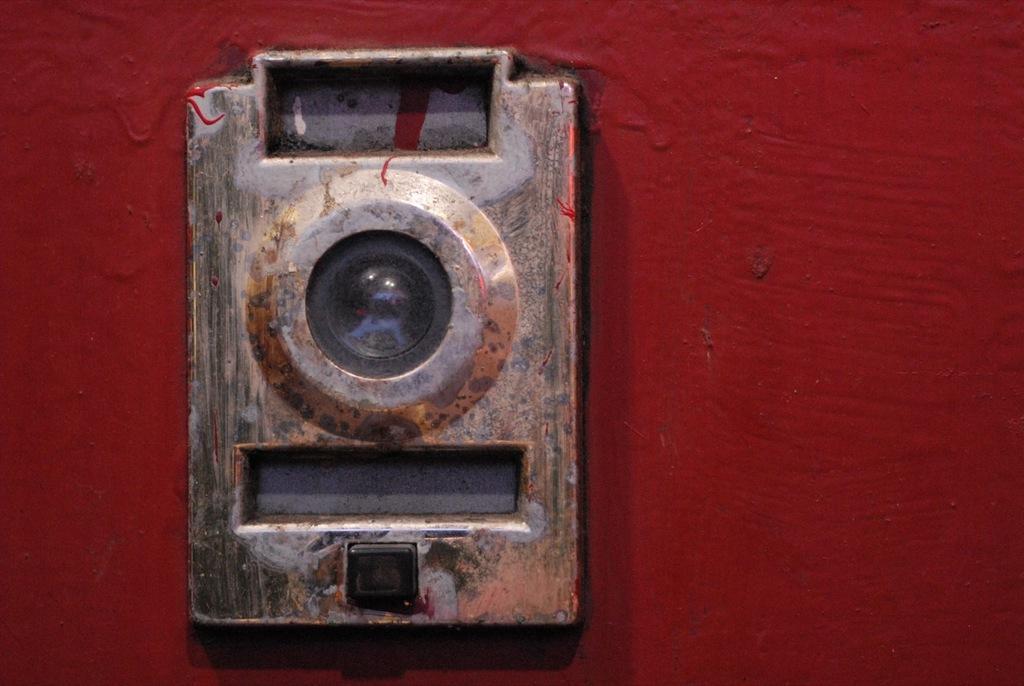Describe this image in one or two sentences. In this image we can see an object. 